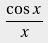<formula> <loc_0><loc_0><loc_500><loc_500>\frac { \cos x } { x }</formula> 